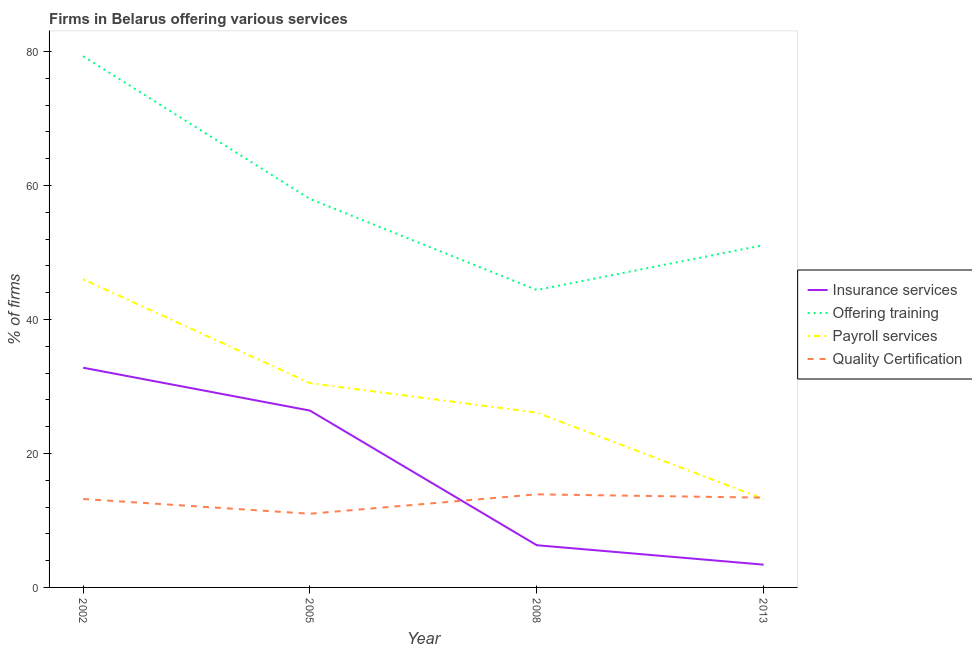Does the line corresponding to percentage of firms offering payroll services intersect with the line corresponding to percentage of firms offering insurance services?
Offer a very short reply. No. Is the number of lines equal to the number of legend labels?
Your answer should be compact. Yes. What is the percentage of firms offering training in 2008?
Your answer should be compact. 44.4. Across all years, what is the maximum percentage of firms offering insurance services?
Your response must be concise. 32.8. In which year was the percentage of firms offering quality certification minimum?
Provide a succinct answer. 2005. What is the total percentage of firms offering payroll services in the graph?
Provide a succinct answer. 115.8. What is the difference between the percentage of firms offering training in 2005 and that in 2013?
Your answer should be compact. 6.9. What is the difference between the percentage of firms offering insurance services in 2005 and the percentage of firms offering training in 2013?
Offer a terse response. -24.7. What is the average percentage of firms offering quality certification per year?
Your response must be concise. 12.88. In the year 2002, what is the difference between the percentage of firms offering insurance services and percentage of firms offering quality certification?
Your response must be concise. 19.6. In how many years, is the percentage of firms offering quality certification greater than 76 %?
Give a very brief answer. 0. What is the ratio of the percentage of firms offering payroll services in 2005 to that in 2008?
Your answer should be very brief. 1.17. Is the percentage of firms offering insurance services in 2002 less than that in 2013?
Make the answer very short. No. Is the difference between the percentage of firms offering quality certification in 2002 and 2013 greater than the difference between the percentage of firms offering payroll services in 2002 and 2013?
Give a very brief answer. No. What is the difference between the highest and the second highest percentage of firms offering training?
Your answer should be very brief. 21.3. What is the difference between the highest and the lowest percentage of firms offering training?
Make the answer very short. 34.9. Is it the case that in every year, the sum of the percentage of firms offering training and percentage of firms offering insurance services is greater than the sum of percentage of firms offering quality certification and percentage of firms offering payroll services?
Your response must be concise. No. Does the percentage of firms offering insurance services monotonically increase over the years?
Offer a very short reply. No. Is the percentage of firms offering training strictly less than the percentage of firms offering insurance services over the years?
Make the answer very short. No. How many years are there in the graph?
Make the answer very short. 4. Where does the legend appear in the graph?
Keep it short and to the point. Center right. How many legend labels are there?
Provide a succinct answer. 4. How are the legend labels stacked?
Provide a short and direct response. Vertical. What is the title of the graph?
Provide a short and direct response. Firms in Belarus offering various services . Does "PFC gas" appear as one of the legend labels in the graph?
Your response must be concise. No. What is the label or title of the X-axis?
Your response must be concise. Year. What is the label or title of the Y-axis?
Your answer should be compact. % of firms. What is the % of firms of Insurance services in 2002?
Give a very brief answer. 32.8. What is the % of firms of Offering training in 2002?
Your response must be concise. 79.3. What is the % of firms in Quality Certification in 2002?
Offer a terse response. 13.2. What is the % of firms in Insurance services in 2005?
Your answer should be very brief. 26.4. What is the % of firms in Payroll services in 2005?
Offer a terse response. 30.5. What is the % of firms in Quality Certification in 2005?
Offer a terse response. 11. What is the % of firms in Offering training in 2008?
Keep it short and to the point. 44.4. What is the % of firms in Payroll services in 2008?
Provide a short and direct response. 26.1. What is the % of firms in Insurance services in 2013?
Offer a terse response. 3.4. What is the % of firms of Offering training in 2013?
Keep it short and to the point. 51.1. Across all years, what is the maximum % of firms of Insurance services?
Offer a terse response. 32.8. Across all years, what is the maximum % of firms of Offering training?
Your answer should be very brief. 79.3. Across all years, what is the maximum % of firms of Quality Certification?
Provide a succinct answer. 13.9. Across all years, what is the minimum % of firms of Offering training?
Your response must be concise. 44.4. Across all years, what is the minimum % of firms of Payroll services?
Provide a succinct answer. 13.2. What is the total % of firms in Insurance services in the graph?
Keep it short and to the point. 68.9. What is the total % of firms in Offering training in the graph?
Ensure brevity in your answer.  232.8. What is the total % of firms in Payroll services in the graph?
Offer a very short reply. 115.8. What is the total % of firms of Quality Certification in the graph?
Your answer should be compact. 51.5. What is the difference between the % of firms of Insurance services in 2002 and that in 2005?
Your answer should be very brief. 6.4. What is the difference between the % of firms in Offering training in 2002 and that in 2005?
Offer a very short reply. 21.3. What is the difference between the % of firms of Insurance services in 2002 and that in 2008?
Make the answer very short. 26.5. What is the difference between the % of firms in Offering training in 2002 and that in 2008?
Ensure brevity in your answer.  34.9. What is the difference between the % of firms in Payroll services in 2002 and that in 2008?
Provide a succinct answer. 19.9. What is the difference between the % of firms of Insurance services in 2002 and that in 2013?
Offer a terse response. 29.4. What is the difference between the % of firms in Offering training in 2002 and that in 2013?
Provide a short and direct response. 28.2. What is the difference between the % of firms in Payroll services in 2002 and that in 2013?
Provide a succinct answer. 32.8. What is the difference between the % of firms of Quality Certification in 2002 and that in 2013?
Provide a succinct answer. -0.2. What is the difference between the % of firms of Insurance services in 2005 and that in 2008?
Your answer should be compact. 20.1. What is the difference between the % of firms of Quality Certification in 2005 and that in 2008?
Provide a short and direct response. -2.9. What is the difference between the % of firms of Offering training in 2008 and that in 2013?
Your answer should be very brief. -6.7. What is the difference between the % of firms of Payroll services in 2008 and that in 2013?
Offer a terse response. 12.9. What is the difference between the % of firms in Quality Certification in 2008 and that in 2013?
Your response must be concise. 0.5. What is the difference between the % of firms of Insurance services in 2002 and the % of firms of Offering training in 2005?
Your answer should be very brief. -25.2. What is the difference between the % of firms in Insurance services in 2002 and the % of firms in Payroll services in 2005?
Your answer should be compact. 2.3. What is the difference between the % of firms in Insurance services in 2002 and the % of firms in Quality Certification in 2005?
Your response must be concise. 21.8. What is the difference between the % of firms of Offering training in 2002 and the % of firms of Payroll services in 2005?
Offer a terse response. 48.8. What is the difference between the % of firms in Offering training in 2002 and the % of firms in Quality Certification in 2005?
Provide a succinct answer. 68.3. What is the difference between the % of firms in Payroll services in 2002 and the % of firms in Quality Certification in 2005?
Give a very brief answer. 35. What is the difference between the % of firms in Insurance services in 2002 and the % of firms in Payroll services in 2008?
Offer a terse response. 6.7. What is the difference between the % of firms of Insurance services in 2002 and the % of firms of Quality Certification in 2008?
Your response must be concise. 18.9. What is the difference between the % of firms of Offering training in 2002 and the % of firms of Payroll services in 2008?
Your answer should be compact. 53.2. What is the difference between the % of firms in Offering training in 2002 and the % of firms in Quality Certification in 2008?
Give a very brief answer. 65.4. What is the difference between the % of firms of Payroll services in 2002 and the % of firms of Quality Certification in 2008?
Provide a short and direct response. 32.1. What is the difference between the % of firms of Insurance services in 2002 and the % of firms of Offering training in 2013?
Offer a very short reply. -18.3. What is the difference between the % of firms in Insurance services in 2002 and the % of firms in Payroll services in 2013?
Make the answer very short. 19.6. What is the difference between the % of firms of Insurance services in 2002 and the % of firms of Quality Certification in 2013?
Provide a succinct answer. 19.4. What is the difference between the % of firms of Offering training in 2002 and the % of firms of Payroll services in 2013?
Provide a succinct answer. 66.1. What is the difference between the % of firms in Offering training in 2002 and the % of firms in Quality Certification in 2013?
Make the answer very short. 65.9. What is the difference between the % of firms in Payroll services in 2002 and the % of firms in Quality Certification in 2013?
Offer a terse response. 32.6. What is the difference between the % of firms of Insurance services in 2005 and the % of firms of Payroll services in 2008?
Give a very brief answer. 0.3. What is the difference between the % of firms of Insurance services in 2005 and the % of firms of Quality Certification in 2008?
Give a very brief answer. 12.5. What is the difference between the % of firms in Offering training in 2005 and the % of firms in Payroll services in 2008?
Offer a terse response. 31.9. What is the difference between the % of firms in Offering training in 2005 and the % of firms in Quality Certification in 2008?
Provide a succinct answer. 44.1. What is the difference between the % of firms of Insurance services in 2005 and the % of firms of Offering training in 2013?
Provide a succinct answer. -24.7. What is the difference between the % of firms of Insurance services in 2005 and the % of firms of Payroll services in 2013?
Your response must be concise. 13.2. What is the difference between the % of firms of Offering training in 2005 and the % of firms of Payroll services in 2013?
Offer a terse response. 44.8. What is the difference between the % of firms in Offering training in 2005 and the % of firms in Quality Certification in 2013?
Your answer should be very brief. 44.6. What is the difference between the % of firms of Payroll services in 2005 and the % of firms of Quality Certification in 2013?
Provide a succinct answer. 17.1. What is the difference between the % of firms in Insurance services in 2008 and the % of firms in Offering training in 2013?
Provide a succinct answer. -44.8. What is the difference between the % of firms in Insurance services in 2008 and the % of firms in Quality Certification in 2013?
Provide a short and direct response. -7.1. What is the difference between the % of firms in Offering training in 2008 and the % of firms in Payroll services in 2013?
Make the answer very short. 31.2. What is the average % of firms in Insurance services per year?
Your response must be concise. 17.23. What is the average % of firms in Offering training per year?
Keep it short and to the point. 58.2. What is the average % of firms of Payroll services per year?
Your response must be concise. 28.95. What is the average % of firms in Quality Certification per year?
Your response must be concise. 12.88. In the year 2002, what is the difference between the % of firms of Insurance services and % of firms of Offering training?
Offer a very short reply. -46.5. In the year 2002, what is the difference between the % of firms in Insurance services and % of firms in Payroll services?
Provide a short and direct response. -13.2. In the year 2002, what is the difference between the % of firms of Insurance services and % of firms of Quality Certification?
Provide a short and direct response. 19.6. In the year 2002, what is the difference between the % of firms of Offering training and % of firms of Payroll services?
Keep it short and to the point. 33.3. In the year 2002, what is the difference between the % of firms in Offering training and % of firms in Quality Certification?
Keep it short and to the point. 66.1. In the year 2002, what is the difference between the % of firms of Payroll services and % of firms of Quality Certification?
Make the answer very short. 32.8. In the year 2005, what is the difference between the % of firms in Insurance services and % of firms in Offering training?
Offer a terse response. -31.6. In the year 2005, what is the difference between the % of firms of Payroll services and % of firms of Quality Certification?
Provide a succinct answer. 19.5. In the year 2008, what is the difference between the % of firms of Insurance services and % of firms of Offering training?
Make the answer very short. -38.1. In the year 2008, what is the difference between the % of firms in Insurance services and % of firms in Payroll services?
Keep it short and to the point. -19.8. In the year 2008, what is the difference between the % of firms of Insurance services and % of firms of Quality Certification?
Your answer should be very brief. -7.6. In the year 2008, what is the difference between the % of firms in Offering training and % of firms in Quality Certification?
Your answer should be compact. 30.5. In the year 2008, what is the difference between the % of firms in Payroll services and % of firms in Quality Certification?
Make the answer very short. 12.2. In the year 2013, what is the difference between the % of firms in Insurance services and % of firms in Offering training?
Ensure brevity in your answer.  -47.7. In the year 2013, what is the difference between the % of firms of Insurance services and % of firms of Payroll services?
Your answer should be very brief. -9.8. In the year 2013, what is the difference between the % of firms in Offering training and % of firms in Payroll services?
Keep it short and to the point. 37.9. In the year 2013, what is the difference between the % of firms of Offering training and % of firms of Quality Certification?
Your answer should be compact. 37.7. What is the ratio of the % of firms in Insurance services in 2002 to that in 2005?
Provide a short and direct response. 1.24. What is the ratio of the % of firms in Offering training in 2002 to that in 2005?
Your answer should be very brief. 1.37. What is the ratio of the % of firms in Payroll services in 2002 to that in 2005?
Provide a succinct answer. 1.51. What is the ratio of the % of firms in Quality Certification in 2002 to that in 2005?
Offer a terse response. 1.2. What is the ratio of the % of firms in Insurance services in 2002 to that in 2008?
Provide a short and direct response. 5.21. What is the ratio of the % of firms in Offering training in 2002 to that in 2008?
Your answer should be very brief. 1.79. What is the ratio of the % of firms of Payroll services in 2002 to that in 2008?
Give a very brief answer. 1.76. What is the ratio of the % of firms in Quality Certification in 2002 to that in 2008?
Provide a succinct answer. 0.95. What is the ratio of the % of firms in Insurance services in 2002 to that in 2013?
Keep it short and to the point. 9.65. What is the ratio of the % of firms in Offering training in 2002 to that in 2013?
Ensure brevity in your answer.  1.55. What is the ratio of the % of firms of Payroll services in 2002 to that in 2013?
Give a very brief answer. 3.48. What is the ratio of the % of firms of Quality Certification in 2002 to that in 2013?
Make the answer very short. 0.99. What is the ratio of the % of firms in Insurance services in 2005 to that in 2008?
Make the answer very short. 4.19. What is the ratio of the % of firms in Offering training in 2005 to that in 2008?
Offer a very short reply. 1.31. What is the ratio of the % of firms in Payroll services in 2005 to that in 2008?
Offer a very short reply. 1.17. What is the ratio of the % of firms of Quality Certification in 2005 to that in 2008?
Your answer should be compact. 0.79. What is the ratio of the % of firms in Insurance services in 2005 to that in 2013?
Offer a very short reply. 7.76. What is the ratio of the % of firms of Offering training in 2005 to that in 2013?
Give a very brief answer. 1.14. What is the ratio of the % of firms in Payroll services in 2005 to that in 2013?
Offer a terse response. 2.31. What is the ratio of the % of firms of Quality Certification in 2005 to that in 2013?
Keep it short and to the point. 0.82. What is the ratio of the % of firms of Insurance services in 2008 to that in 2013?
Your answer should be very brief. 1.85. What is the ratio of the % of firms in Offering training in 2008 to that in 2013?
Offer a very short reply. 0.87. What is the ratio of the % of firms in Payroll services in 2008 to that in 2013?
Ensure brevity in your answer.  1.98. What is the ratio of the % of firms in Quality Certification in 2008 to that in 2013?
Keep it short and to the point. 1.04. What is the difference between the highest and the second highest % of firms of Insurance services?
Keep it short and to the point. 6.4. What is the difference between the highest and the second highest % of firms of Offering training?
Your answer should be compact. 21.3. What is the difference between the highest and the second highest % of firms in Payroll services?
Keep it short and to the point. 15.5. What is the difference between the highest and the lowest % of firms in Insurance services?
Offer a very short reply. 29.4. What is the difference between the highest and the lowest % of firms of Offering training?
Give a very brief answer. 34.9. What is the difference between the highest and the lowest % of firms of Payroll services?
Make the answer very short. 32.8. 